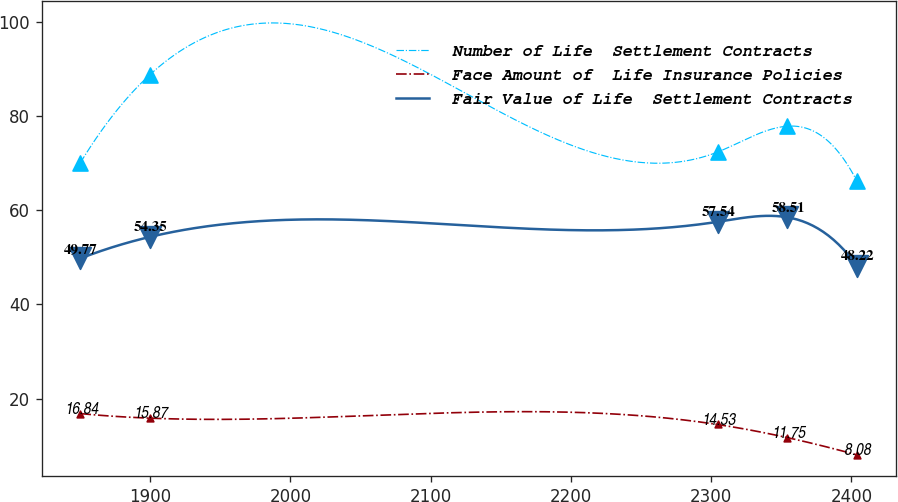<chart> <loc_0><loc_0><loc_500><loc_500><line_chart><ecel><fcel>Number of Life  Settlement Contracts<fcel>Face Amount of  Life Insurance Policies<fcel>Fair Value of Life  Settlement Contracts<nl><fcel>1850.18<fcel>70.09<fcel>16.84<fcel>49.77<nl><fcel>1899.88<fcel>88.79<fcel>15.87<fcel>54.35<nl><fcel>2304.59<fcel>72.35<fcel>14.53<fcel>57.54<nl><fcel>2354.29<fcel>77.84<fcel>11.75<fcel>58.51<nl><fcel>2403.99<fcel>66.19<fcel>8.08<fcel>48.22<nl></chart> 